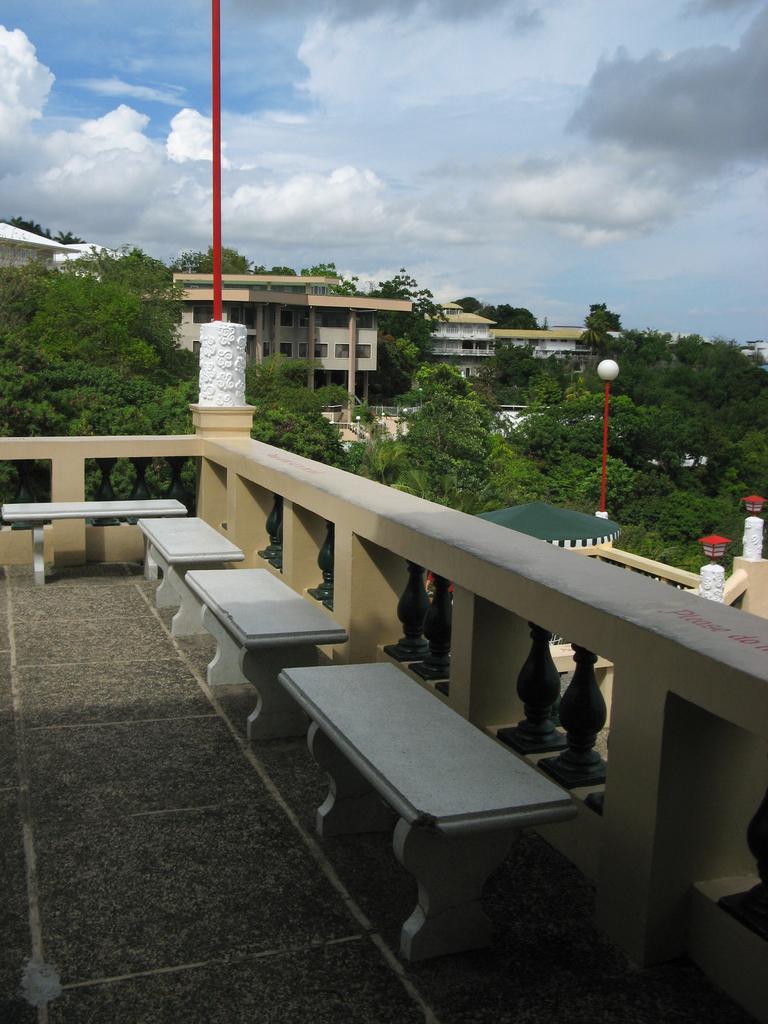Please provide a concise description of this image. In the image we can see some benches. Behind the benches there is fencing. Behind the fencing there are some trees and buildings and poles. At the top of the image there are some clouds and sky. 